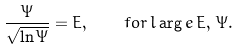<formula> <loc_0><loc_0><loc_500><loc_500>\frac { \Psi } { \sqrt { \ln \Psi } } = E , \quad f o r \, l \arg e \, E , \, \Psi .</formula> 